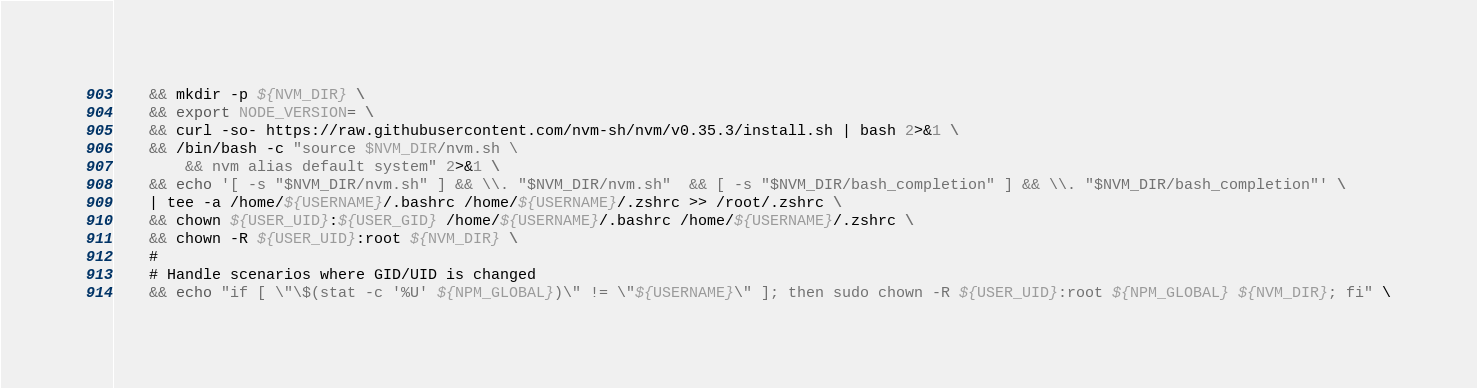Convert code to text. <code><loc_0><loc_0><loc_500><loc_500><_Dockerfile_>    && mkdir -p ${NVM_DIR} \
    && export NODE_VERSION= \
    && curl -so- https://raw.githubusercontent.com/nvm-sh/nvm/v0.35.3/install.sh | bash 2>&1 \
    && /bin/bash -c "source $NVM_DIR/nvm.sh \
        && nvm alias default system" 2>&1 \
    && echo '[ -s "$NVM_DIR/nvm.sh" ] && \\. "$NVM_DIR/nvm.sh"  && [ -s "$NVM_DIR/bash_completion" ] && \\. "$NVM_DIR/bash_completion"' \ 
    | tee -a /home/${USERNAME}/.bashrc /home/${USERNAME}/.zshrc >> /root/.zshrc \
    && chown ${USER_UID}:${USER_GID} /home/${USERNAME}/.bashrc /home/${USERNAME}/.zshrc \
    && chown -R ${USER_UID}:root ${NVM_DIR} \
    #
    # Handle scenarios where GID/UID is changed
    && echo "if [ \"\$(stat -c '%U' ${NPM_GLOBAL})\" != \"${USERNAME}\" ]; then sudo chown -R ${USER_UID}:root ${NPM_GLOBAL} ${NVM_DIR}; fi" \</code> 